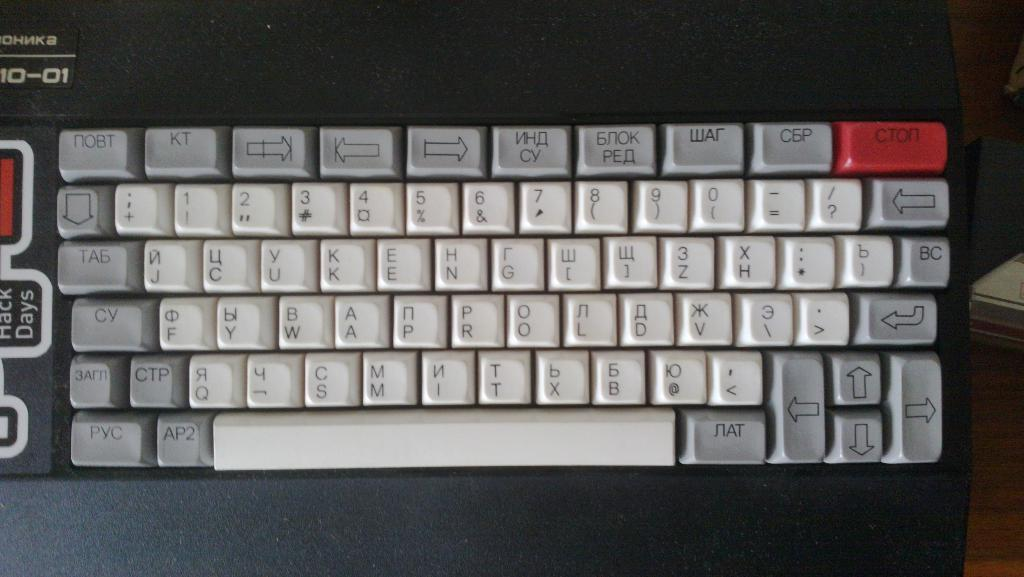Provide a one-sentence caption for the provided image. Ohnka keyboard that is black, white, gray, and red. 